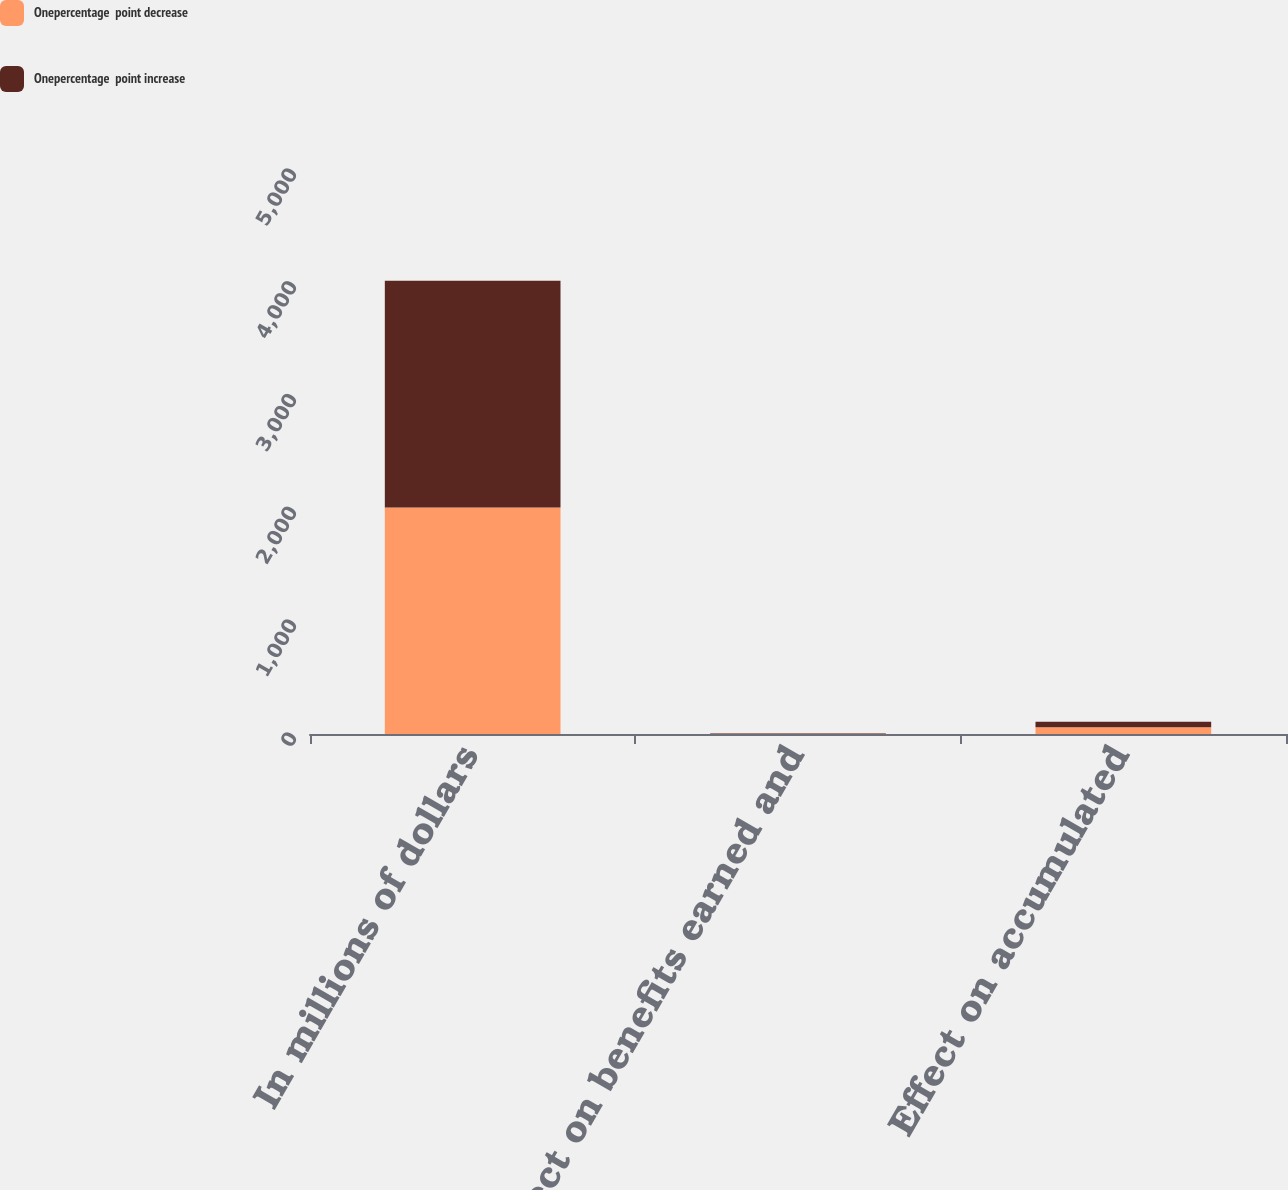Convert chart to OTSL. <chart><loc_0><loc_0><loc_500><loc_500><stacked_bar_chart><ecel><fcel>In millions of dollars<fcel>Effect on benefits earned and<fcel>Effect on accumulated<nl><fcel>Onepercentage  point decrease<fcel>2009<fcel>3<fcel>60<nl><fcel>Onepercentage  point increase<fcel>2009<fcel>3<fcel>49<nl></chart> 